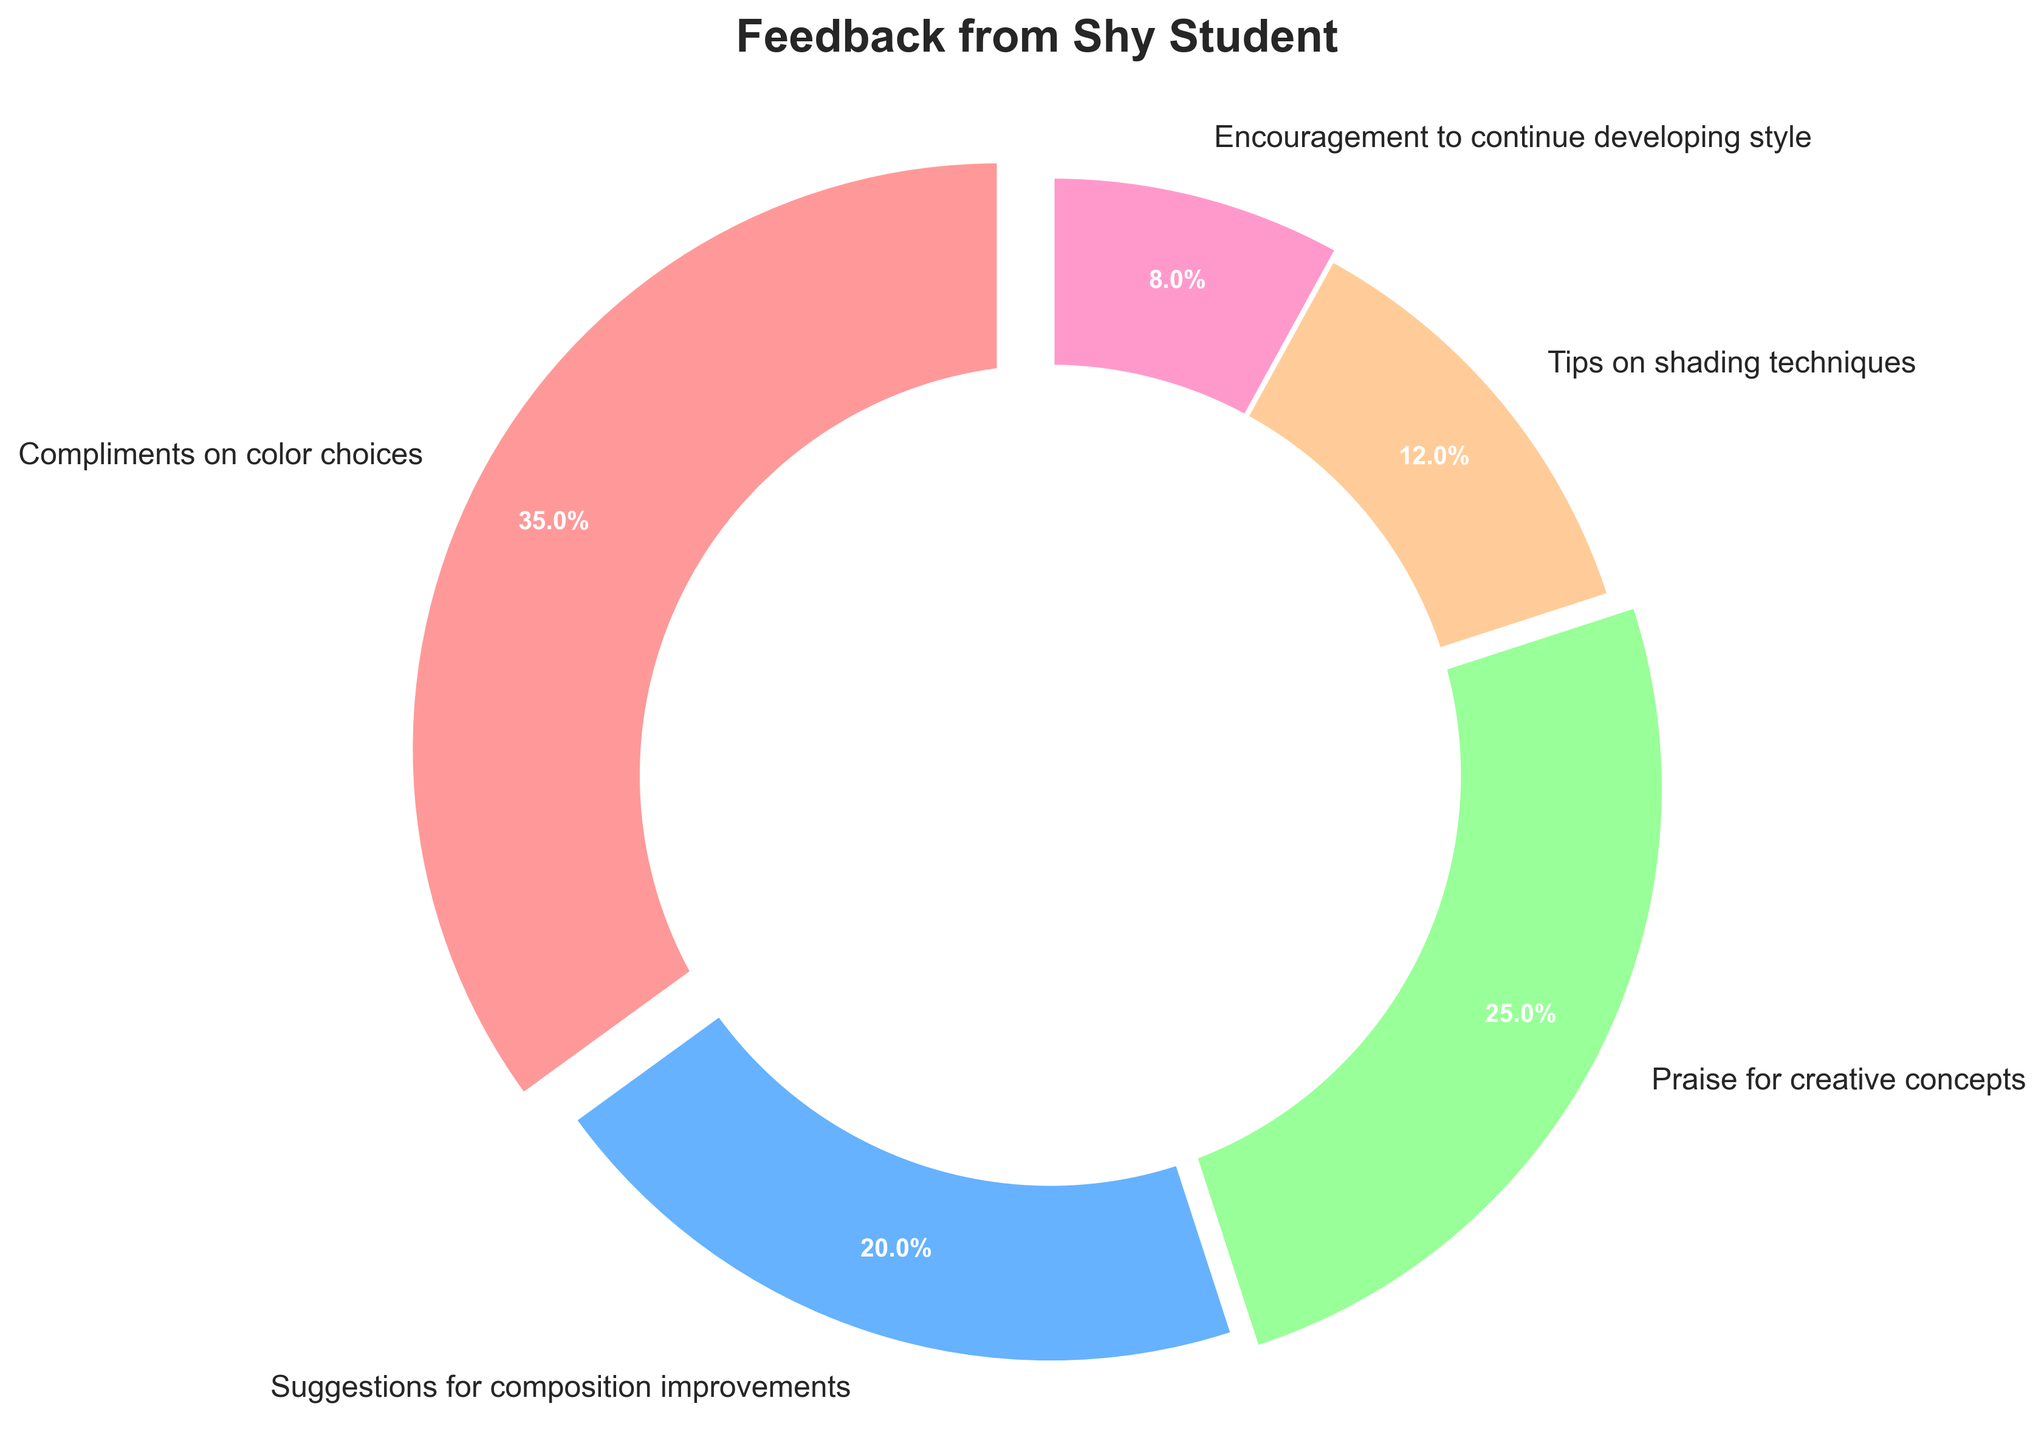What percentage of feedback was praises for creative concepts? The figure shows a segment labeled "Praise for creative concepts" with a percentage value. Locate this segment and read the percentage value indicated.
Answer: 25% What is the total percentage of feedback that was either suggestions for composition improvements or praises for creative concepts? Add the percentage values for "Suggestions for composition improvements" (20%) and "Praise for creative concepts" (25%). 20 + 25 = 45
Answer: 45% Which type of feedback received the smallest percentage? Identify the segment with the smallest percentage value in the pie chart. The segment labeled "Encouragement to continue developing style" has the smallest given value.
Answer: Encouragement to continue developing style What is the difference in the percentage between compliments on color choices and tips on shading techniques? Subtract the percentage for "Tips on shading techniques" (12%) from "Compliments on color choices" (35%). 35 - 12 = 23
Answer: 23% Which feedback type is represented with the slightly exploded slice, and what is its percentage? Look for the slice that is just slightly separated from the rest and identify its label and percentage. The "Praise for creative concepts" is shown with the slightly exploded slice at 25%.
Answer: Praise for creative concepts, 25% What is the total percentage of positive feedback (compliments, praise, and encouragement)? Sum the percentages of "Compliments on color choices" (35%), "Praise for creative concepts" (25%), and "Encouragement to continue developing style" (8%). 35 + 25 + 8 = 68
Answer: 68% Is the percentage of suggestions for composition improvements more than or less than 1/5 of the total feedback? As 1/5 of the total feedback (100%) is 20%, compare this with the percentage for "Suggestions for composition improvements", which is also 20%. They are equal.
Answer: Equal What percent more is the total of compliments on color choices and tips on shading techniques combined compared to encouragement to continue developing style? First, sum "Compliments on color choices" (35%) and "Tips on shading techniques" (12%). 35 + 12 = 47. Then subtract "Encouragement to continue developing style" (8%) from 47. 47 - 8 = 39.
Answer: 39% 